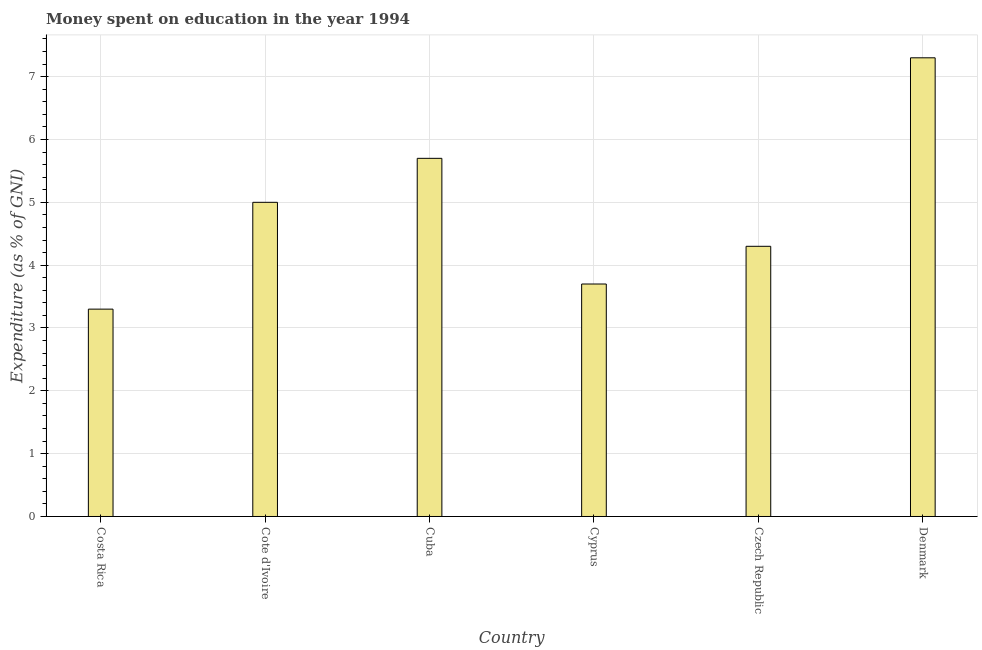What is the title of the graph?
Offer a very short reply. Money spent on education in the year 1994. What is the label or title of the Y-axis?
Ensure brevity in your answer.  Expenditure (as % of GNI). What is the expenditure on education in Czech Republic?
Offer a terse response. 4.3. Across all countries, what is the maximum expenditure on education?
Provide a short and direct response. 7.3. Across all countries, what is the minimum expenditure on education?
Your answer should be very brief. 3.3. In which country was the expenditure on education maximum?
Provide a short and direct response. Denmark. In which country was the expenditure on education minimum?
Provide a succinct answer. Costa Rica. What is the sum of the expenditure on education?
Offer a very short reply. 29.3. What is the average expenditure on education per country?
Your answer should be compact. 4.88. What is the median expenditure on education?
Provide a short and direct response. 4.65. What is the ratio of the expenditure on education in Costa Rica to that in Denmark?
Offer a terse response. 0.45. Is the difference between the expenditure on education in Costa Rica and Cyprus greater than the difference between any two countries?
Ensure brevity in your answer.  No. Is the sum of the expenditure on education in Cote d'Ivoire and Cyprus greater than the maximum expenditure on education across all countries?
Your answer should be compact. Yes. How many countries are there in the graph?
Your answer should be very brief. 6. Are the values on the major ticks of Y-axis written in scientific E-notation?
Your answer should be compact. No. What is the Expenditure (as % of GNI) of Costa Rica?
Make the answer very short. 3.3. What is the Expenditure (as % of GNI) in Cote d'Ivoire?
Your answer should be very brief. 5. What is the Expenditure (as % of GNI) of Cuba?
Keep it short and to the point. 5.7. What is the difference between the Expenditure (as % of GNI) in Costa Rica and Cote d'Ivoire?
Your response must be concise. -1.7. What is the difference between the Expenditure (as % of GNI) in Costa Rica and Cuba?
Your response must be concise. -2.4. What is the difference between the Expenditure (as % of GNI) in Cote d'Ivoire and Cyprus?
Provide a short and direct response. 1.3. What is the difference between the Expenditure (as % of GNI) in Cuba and Cyprus?
Your answer should be compact. 2. What is the difference between the Expenditure (as % of GNI) in Cuba and Czech Republic?
Offer a terse response. 1.4. What is the difference between the Expenditure (as % of GNI) in Cuba and Denmark?
Your response must be concise. -1.6. What is the difference between the Expenditure (as % of GNI) in Cyprus and Denmark?
Your answer should be very brief. -3.6. What is the difference between the Expenditure (as % of GNI) in Czech Republic and Denmark?
Provide a short and direct response. -3. What is the ratio of the Expenditure (as % of GNI) in Costa Rica to that in Cote d'Ivoire?
Your response must be concise. 0.66. What is the ratio of the Expenditure (as % of GNI) in Costa Rica to that in Cuba?
Give a very brief answer. 0.58. What is the ratio of the Expenditure (as % of GNI) in Costa Rica to that in Cyprus?
Offer a terse response. 0.89. What is the ratio of the Expenditure (as % of GNI) in Costa Rica to that in Czech Republic?
Make the answer very short. 0.77. What is the ratio of the Expenditure (as % of GNI) in Costa Rica to that in Denmark?
Your answer should be very brief. 0.45. What is the ratio of the Expenditure (as % of GNI) in Cote d'Ivoire to that in Cuba?
Offer a very short reply. 0.88. What is the ratio of the Expenditure (as % of GNI) in Cote d'Ivoire to that in Cyprus?
Give a very brief answer. 1.35. What is the ratio of the Expenditure (as % of GNI) in Cote d'Ivoire to that in Czech Republic?
Offer a very short reply. 1.16. What is the ratio of the Expenditure (as % of GNI) in Cote d'Ivoire to that in Denmark?
Give a very brief answer. 0.69. What is the ratio of the Expenditure (as % of GNI) in Cuba to that in Cyprus?
Offer a very short reply. 1.54. What is the ratio of the Expenditure (as % of GNI) in Cuba to that in Czech Republic?
Your answer should be very brief. 1.33. What is the ratio of the Expenditure (as % of GNI) in Cuba to that in Denmark?
Your response must be concise. 0.78. What is the ratio of the Expenditure (as % of GNI) in Cyprus to that in Czech Republic?
Give a very brief answer. 0.86. What is the ratio of the Expenditure (as % of GNI) in Cyprus to that in Denmark?
Offer a terse response. 0.51. What is the ratio of the Expenditure (as % of GNI) in Czech Republic to that in Denmark?
Make the answer very short. 0.59. 